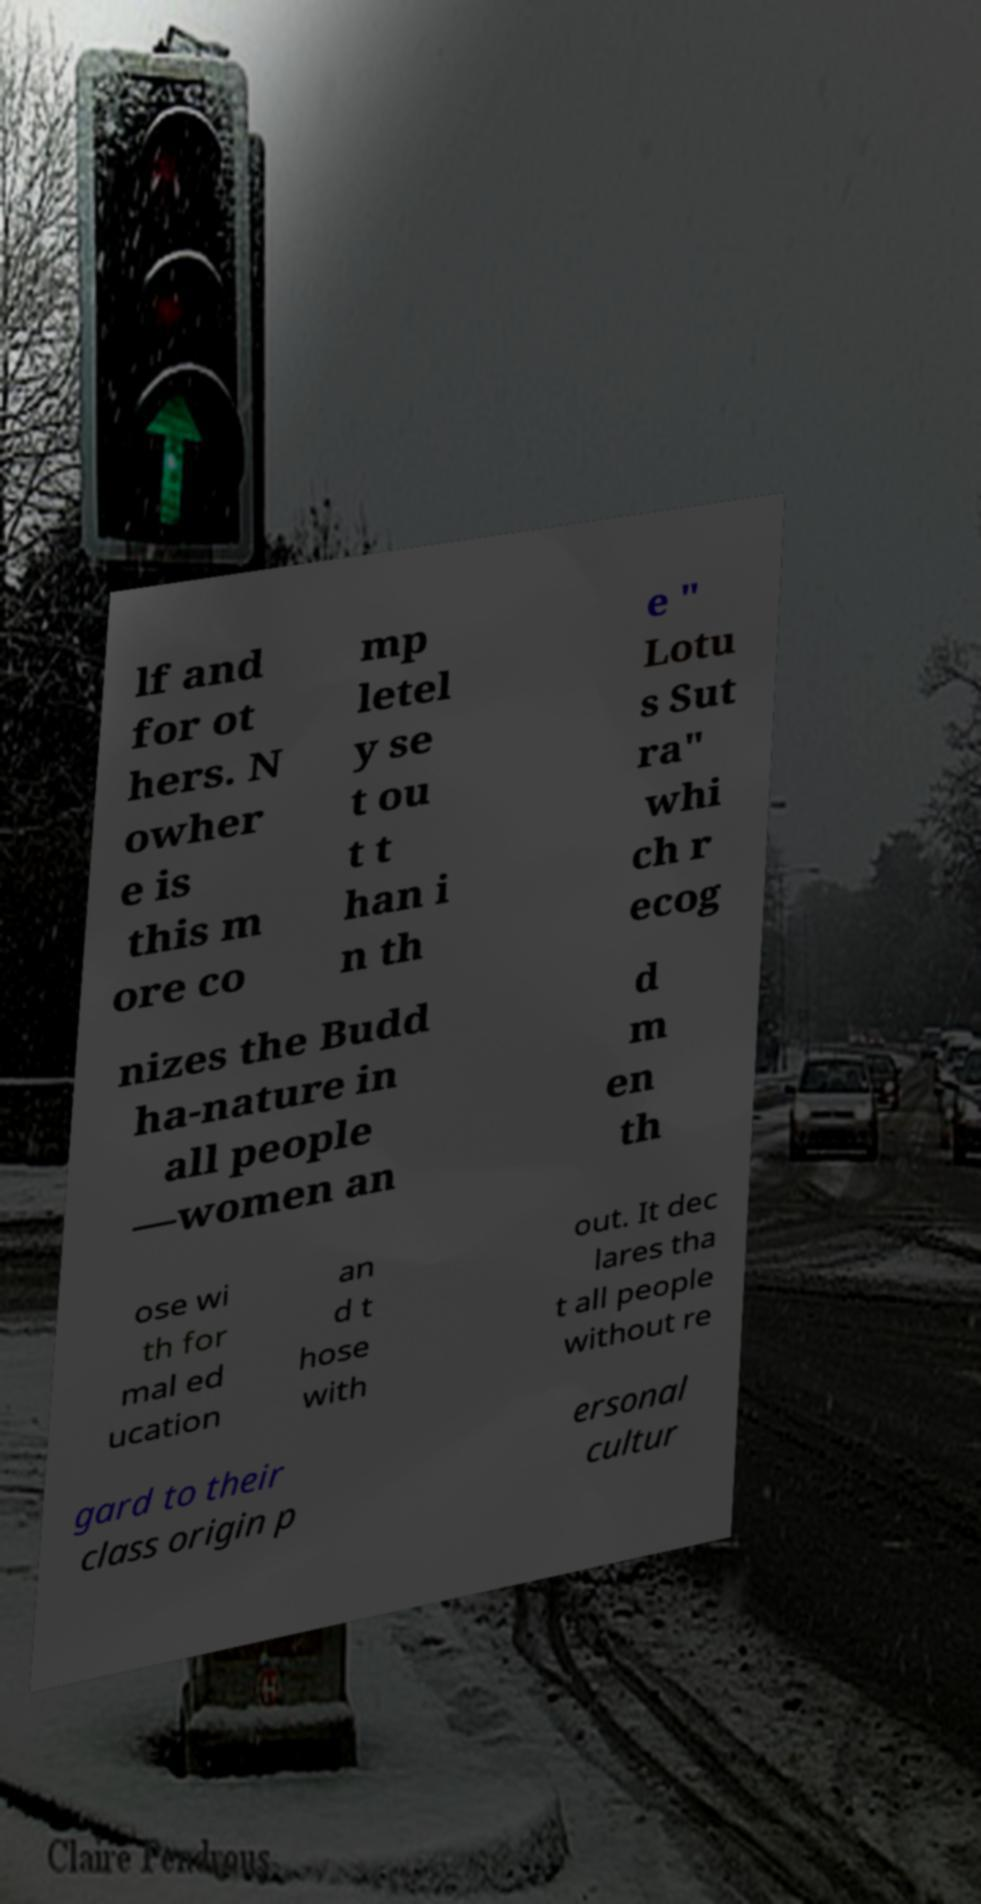Could you extract and type out the text from this image? lf and for ot hers. N owher e is this m ore co mp letel y se t ou t t han i n th e " Lotu s Sut ra" whi ch r ecog nizes the Budd ha-nature in all people —women an d m en th ose wi th for mal ed ucation an d t hose with out. It dec lares tha t all people without re gard to their class origin p ersonal cultur 